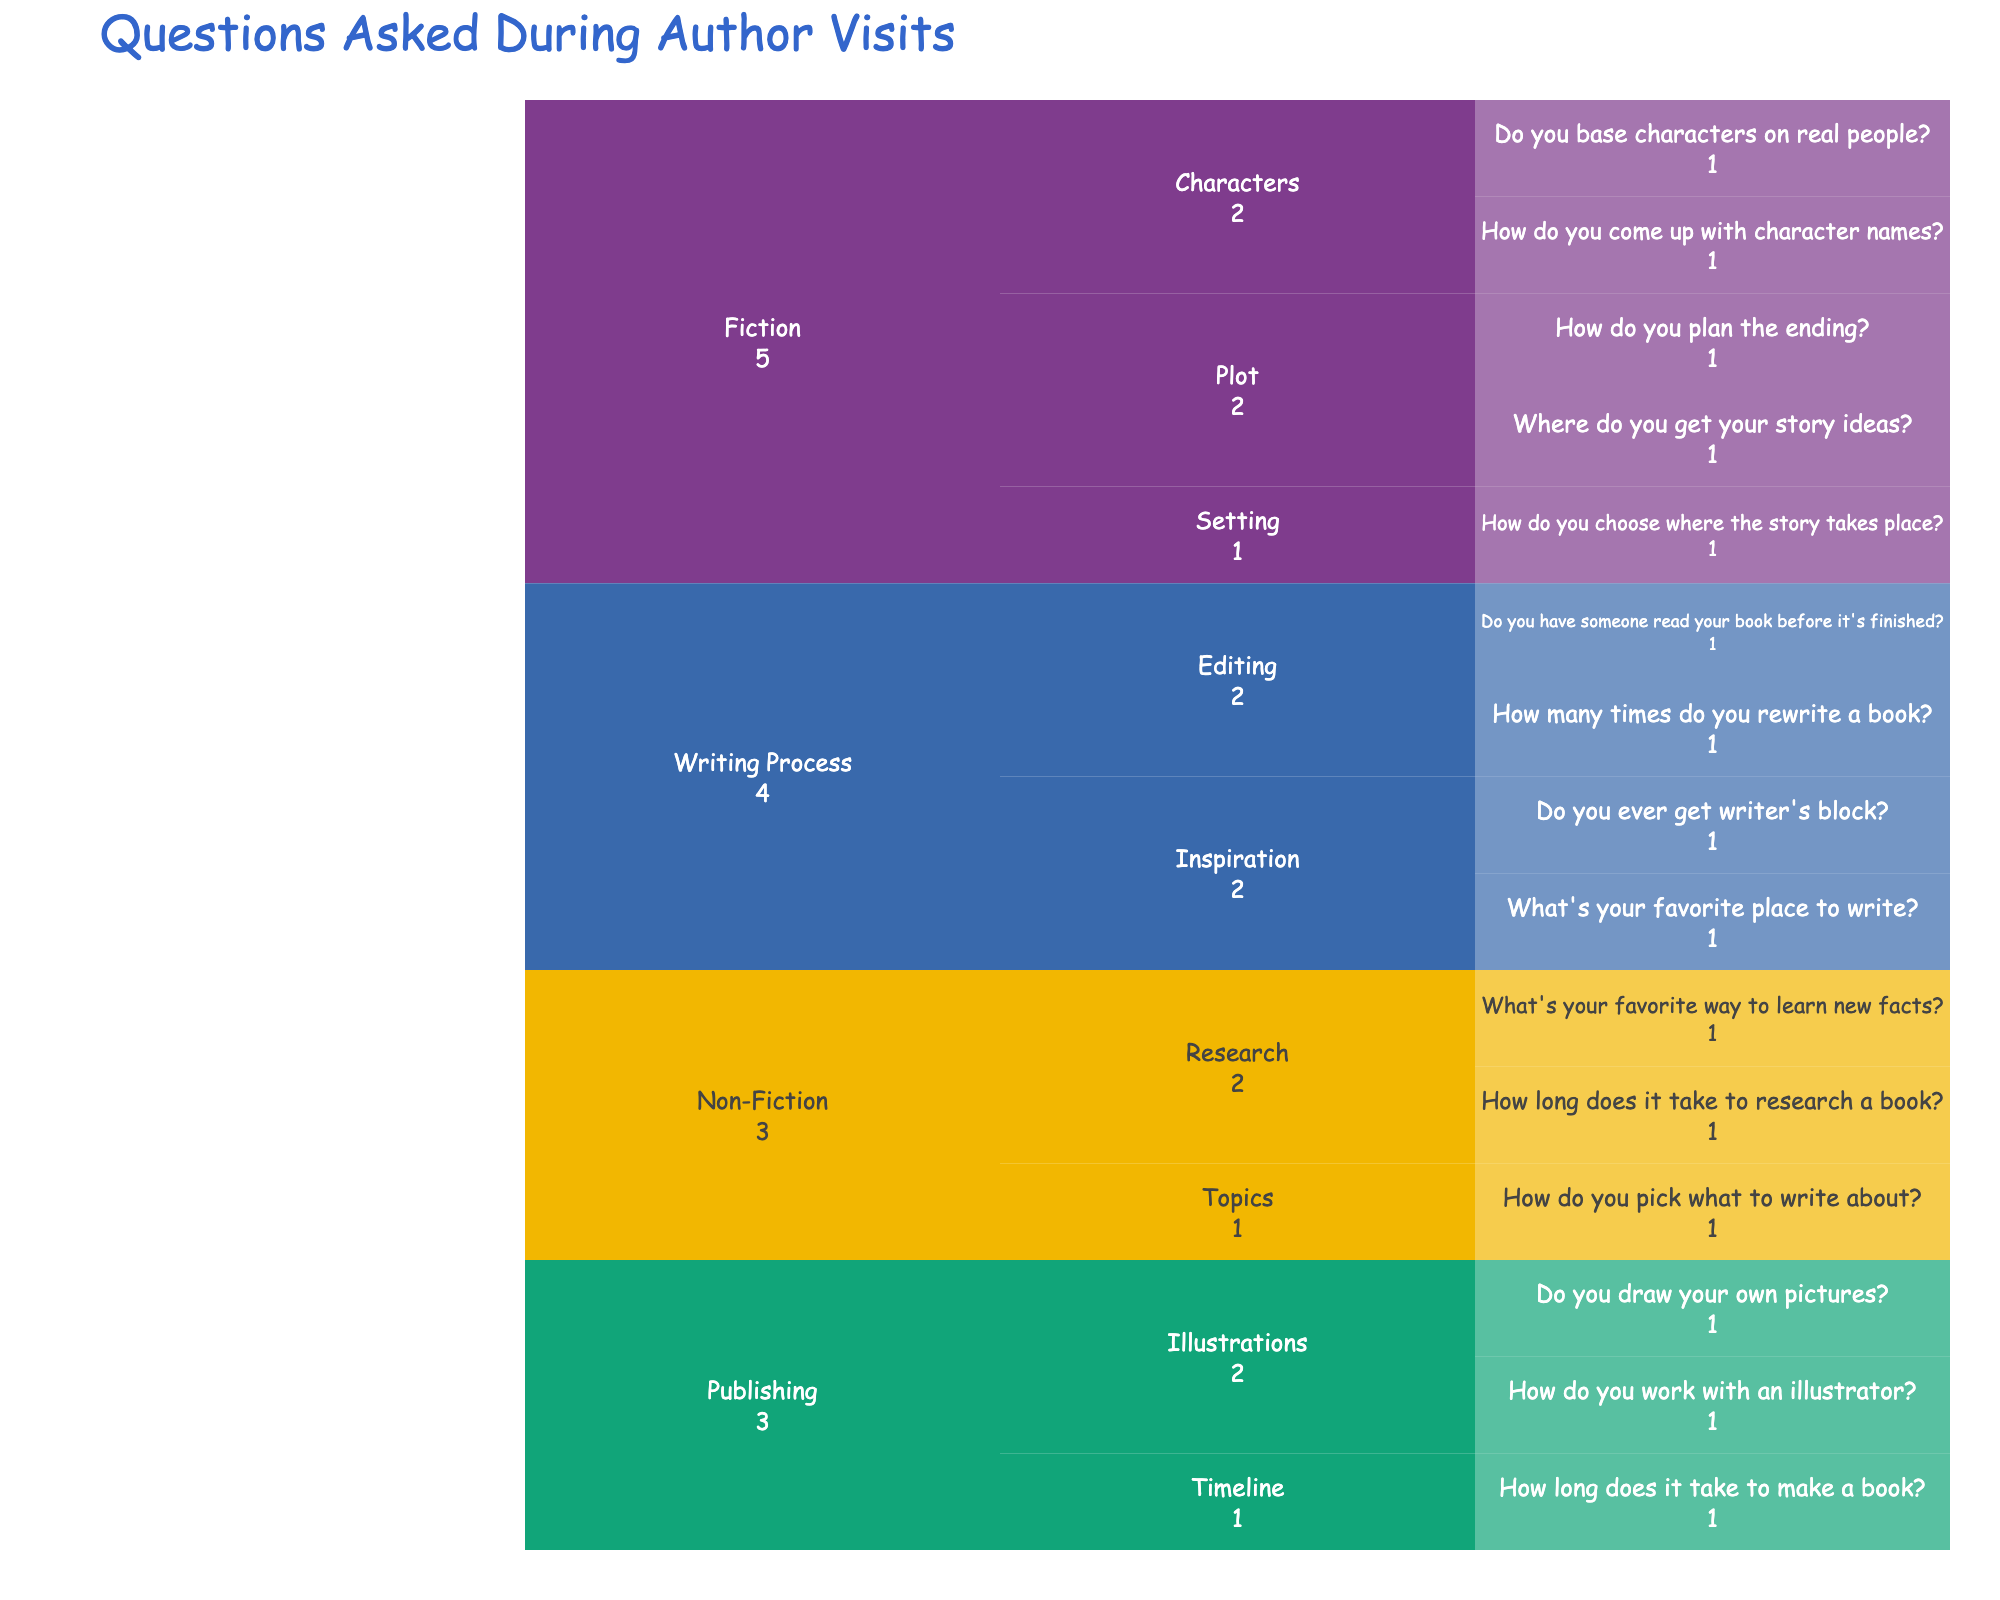What is the title of the chart? The chart's title is usually displayed at the top of the figure.
Answer: Questions Asked During Author Visits How many main topics are there in the chart? The main topics are labeled at the first level of the icicle chart.
Answer: 4 Which topic has the most categories? Count the number of categories (sub-levels) under each main topic.
Answer: Writing Process How many questions are related to the topic of Fiction? Add up all the questions under the Fiction topic. There are 2 questions under Characters, 2 under Plot, and 1 under Setting.
Answer: 5 How many questions are related to the writing process? Add up all the questions under the Writing Process topic. There are 2 questions under Inspiration and 2 under Editing.
Answer: 4 Which category under the Fiction topic has more questions related to it, Characters or Plot? Compare the number of questions listed under the Characters category and the Plot category in the Fiction topic.
Answer: Characters Is there an equal number of questions about Research and Editing? Count the number of questions in the Research and Editing categories and compare them. Research has 2 questions and Editing has 2 questions. So, they are equal.
Answer: Yes What is the color used for Non-Fiction in the chart? Identify the color associated with the Non-Fiction topic by checking the color-coded paths in the icicle chart.
Answer: Green (assuming the color scheme used) What is the category with the smallest number of questions for the Publishing topic? Look at the categories under the Publishing topic and count the questions. Compare the counts to find the smallest category.
Answer: Timeline How many questions does the Illustrator category have? Count the number of questions listed under the Illustrations category of Publishing.
Answer: 2 